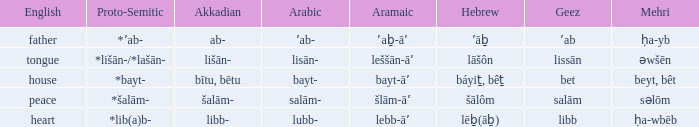If in English it's house, what is it in proto-semitic? *bayt-. 